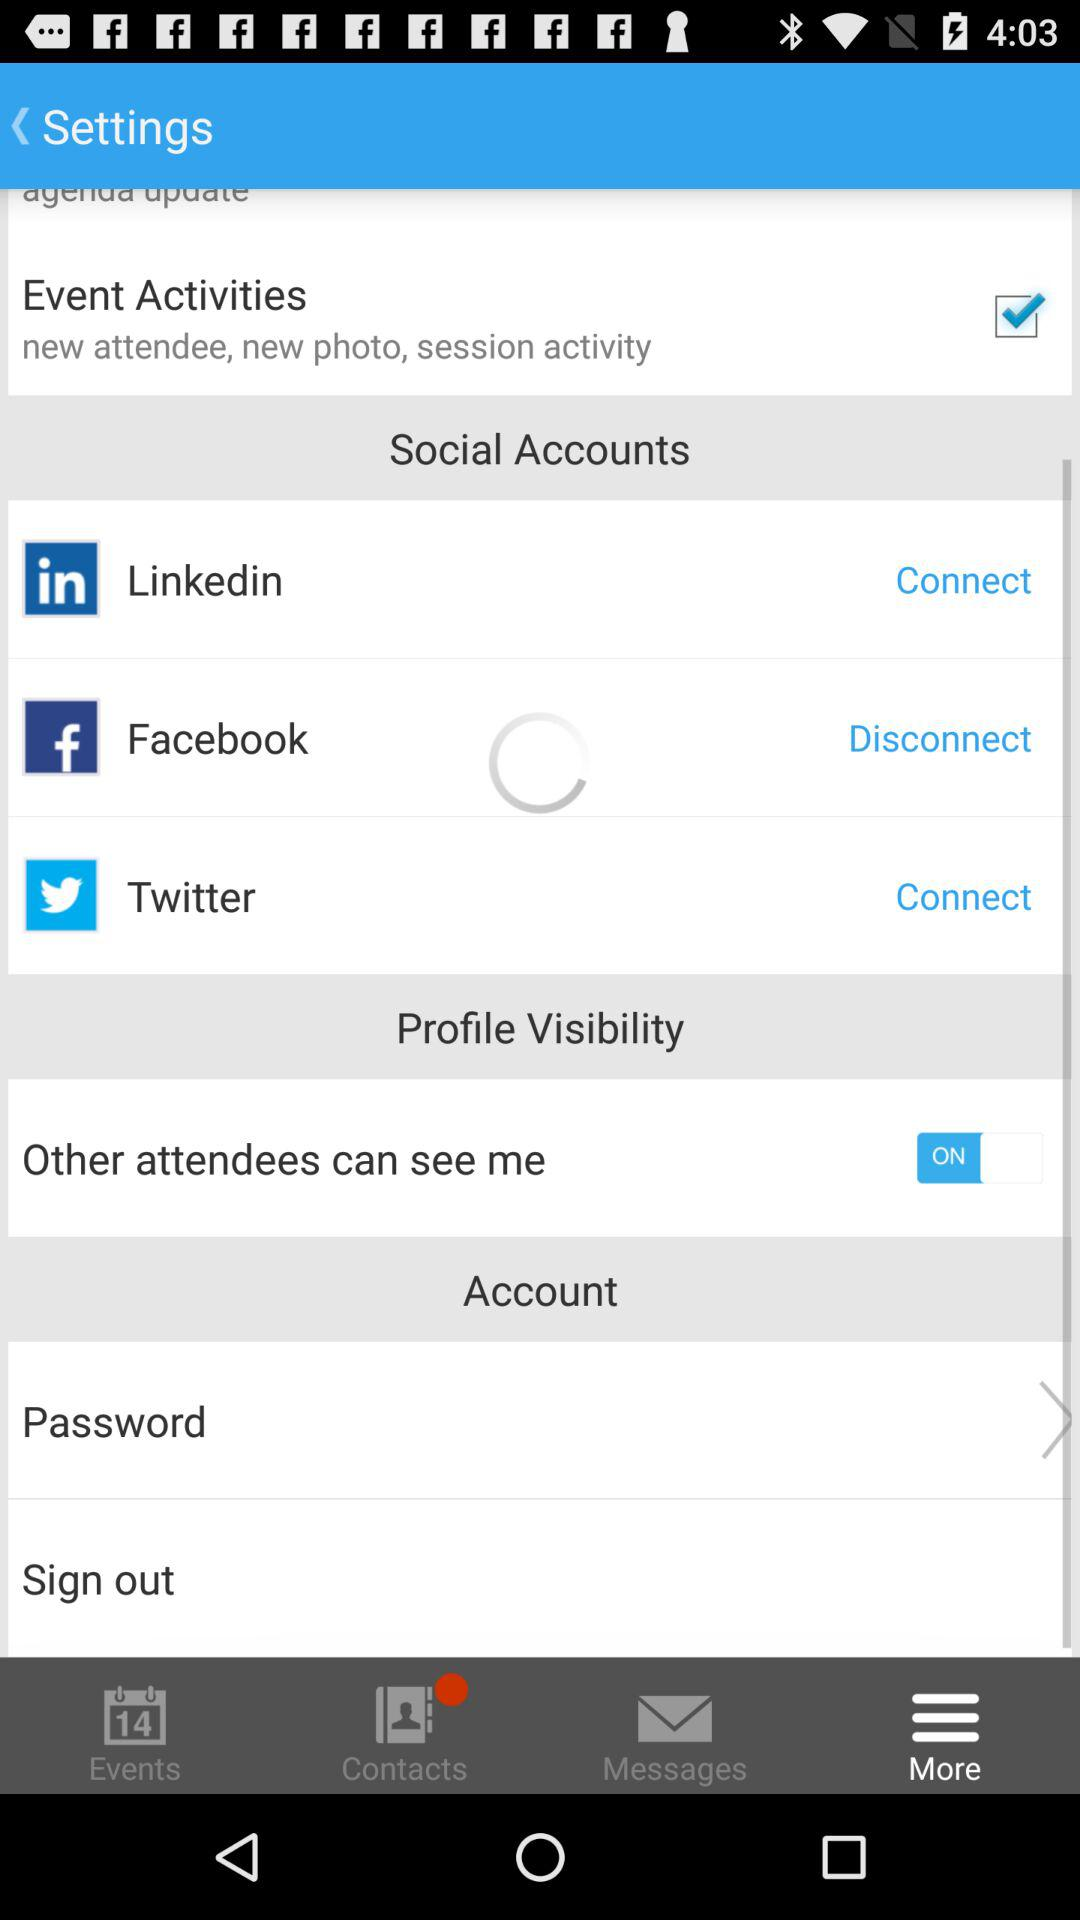How many items are displayed in the Social Accounts section?
Answer the question using a single word or phrase. 3 